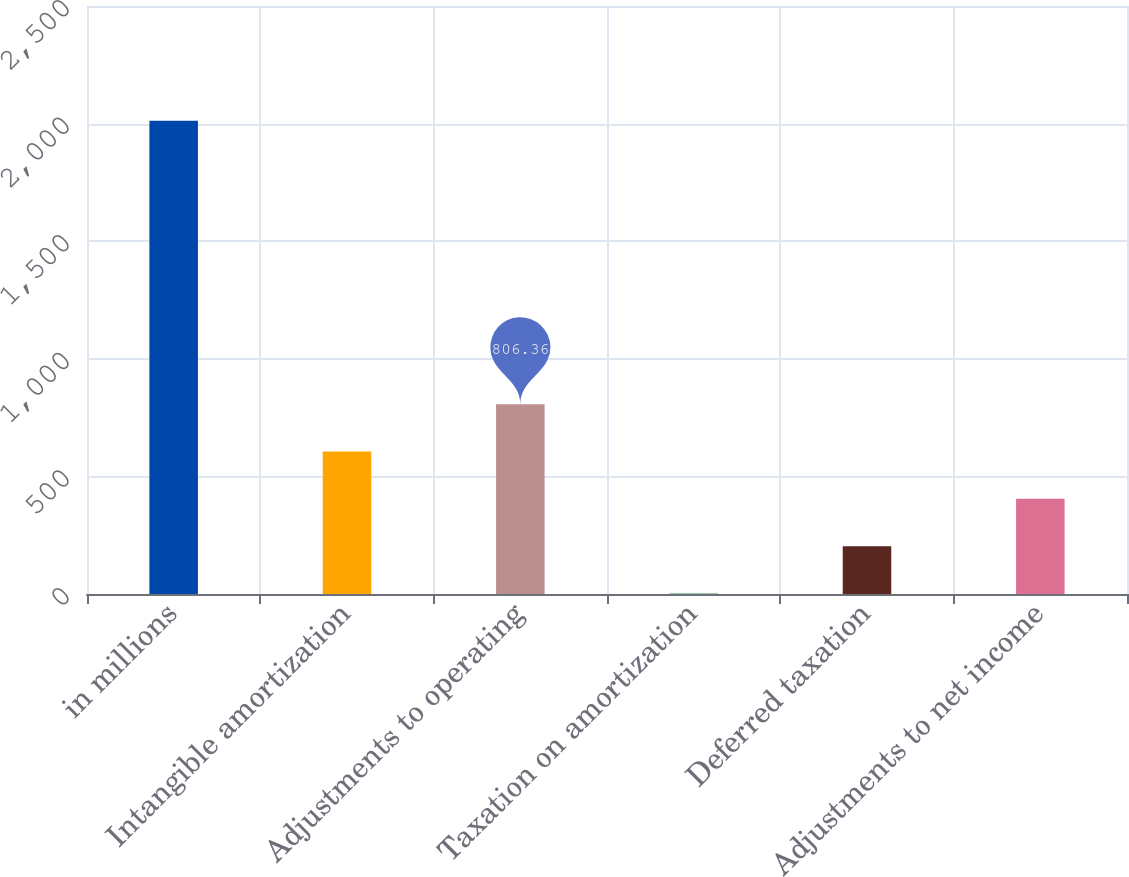Convert chart to OTSL. <chart><loc_0><loc_0><loc_500><loc_500><bar_chart><fcel>in millions<fcel>Intangible amortization<fcel>Adjustments to operating<fcel>Taxation on amortization<fcel>Deferred taxation<fcel>Adjustments to net income<nl><fcel>2012<fcel>605.42<fcel>806.36<fcel>2.6<fcel>203.54<fcel>404.48<nl></chart> 